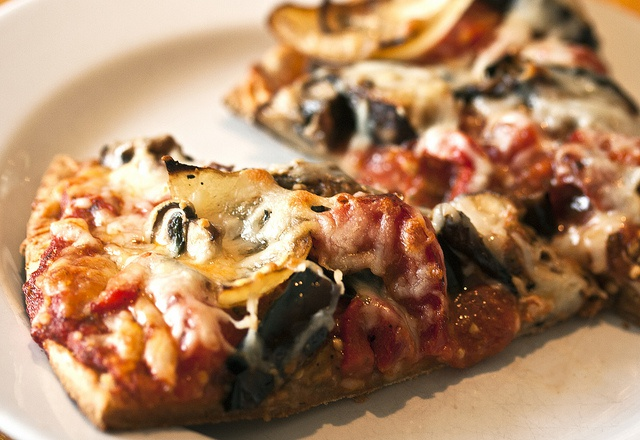Describe the objects in this image and their specific colors. I can see a pizza in orange, maroon, black, and tan tones in this image. 